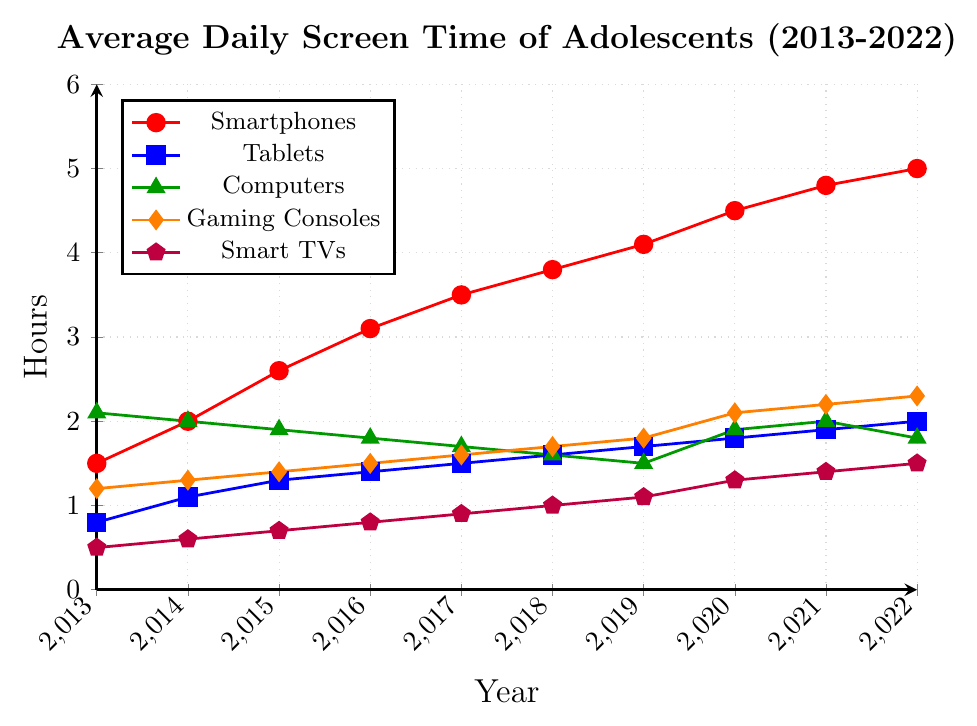What device sees the largest increase in average daily screen time from 2013 to 2022? Look at the points for each device in 2013 and 2022. Calculate the difference for each one: Smartphones (5.0 - 1.5 = 3.5), Tablets (2.0 - 0.8 = 1.2), Computers (1.8 - 2.1 = -0.3), Gaming Consoles (2.3 - 1.2 = 1.1), and Smart TVs (1.5 - 0.5 = 1). The largest difference is for Smartphones
Answer: Smartphones Which device saw a decrease in average daily screen time during the period of 2013 to 2022? Assess the change from 2013 to 2022 for each device. Only Computers saw a decrease from 2.1 to 1.8
Answer: Computers In what year did smartphones surpass 4 hours of average daily screen time? Examine the plotted points for smartphones. In 2019, the daily screen time for smartphones first exceeded 4 hours
Answer: 2019 Between which two consecutive years did Gaming Consoles experience the largest increase in daily screen time? Calculate the year-to-year increases for Gaming Consoles: (2013-2014: 1.3-1.2=0.1), (2014-2015: 1.4-1.3=0.1), (2015-2016: 1.5-1.4=0.1), (2016-2017: 1.6-1.5=0.1), (2017-2018: 1.7-1.6=0.1), (2018-2019: 1.8-1.7=0.1), (2019-2020: 2.1-1.8=0.3), (2020-2021: 2.2-2.1=0.1), (2021-2022: 2.3-2.2=0.1). The largest increase occurred between 2019 and 2020
Answer: 2019-2020 During which years did Tablet usage increase by exactly 0.2 hours? Check the differences in daily screen time for Tablets: (2014-2015: 1.3-1.1=0.2), (2017-2018: 1.6-1.5=0.1), and other differences do not match. So only year 2014-2015 shows an increase by exactly 0.2 hours
Answer: 2014-2015 What was the total average daily screen time across all device types in 2022? Sum the screen times for all devices in 2022: Smartphones (5.0) + Tablets (2.0) + Computers (1.8) + Gaming Consoles (2.3) + Smart TVs (1.5) = 12.6
Answer: 12.6 Which device's screen time trend remained the most stable over the years? Evaluate the overall trend lines. Tablets exhibit the most consistent and gradual increase, suggesting a stable trend
Answer: Tablets What percentage increase did Smart TVs see from 2013 to 2020? Calculate the percentage increase: ((1.3 - 0.5) / 0.5) * 100 = 160%
Answer: 160% Which device had the smallest screen time in 2013 and what was its value? Identify the starting point values in 2013. Smart TVs had the smallest value at 0.5 hours
Answer: Smart TVs, 0.5 